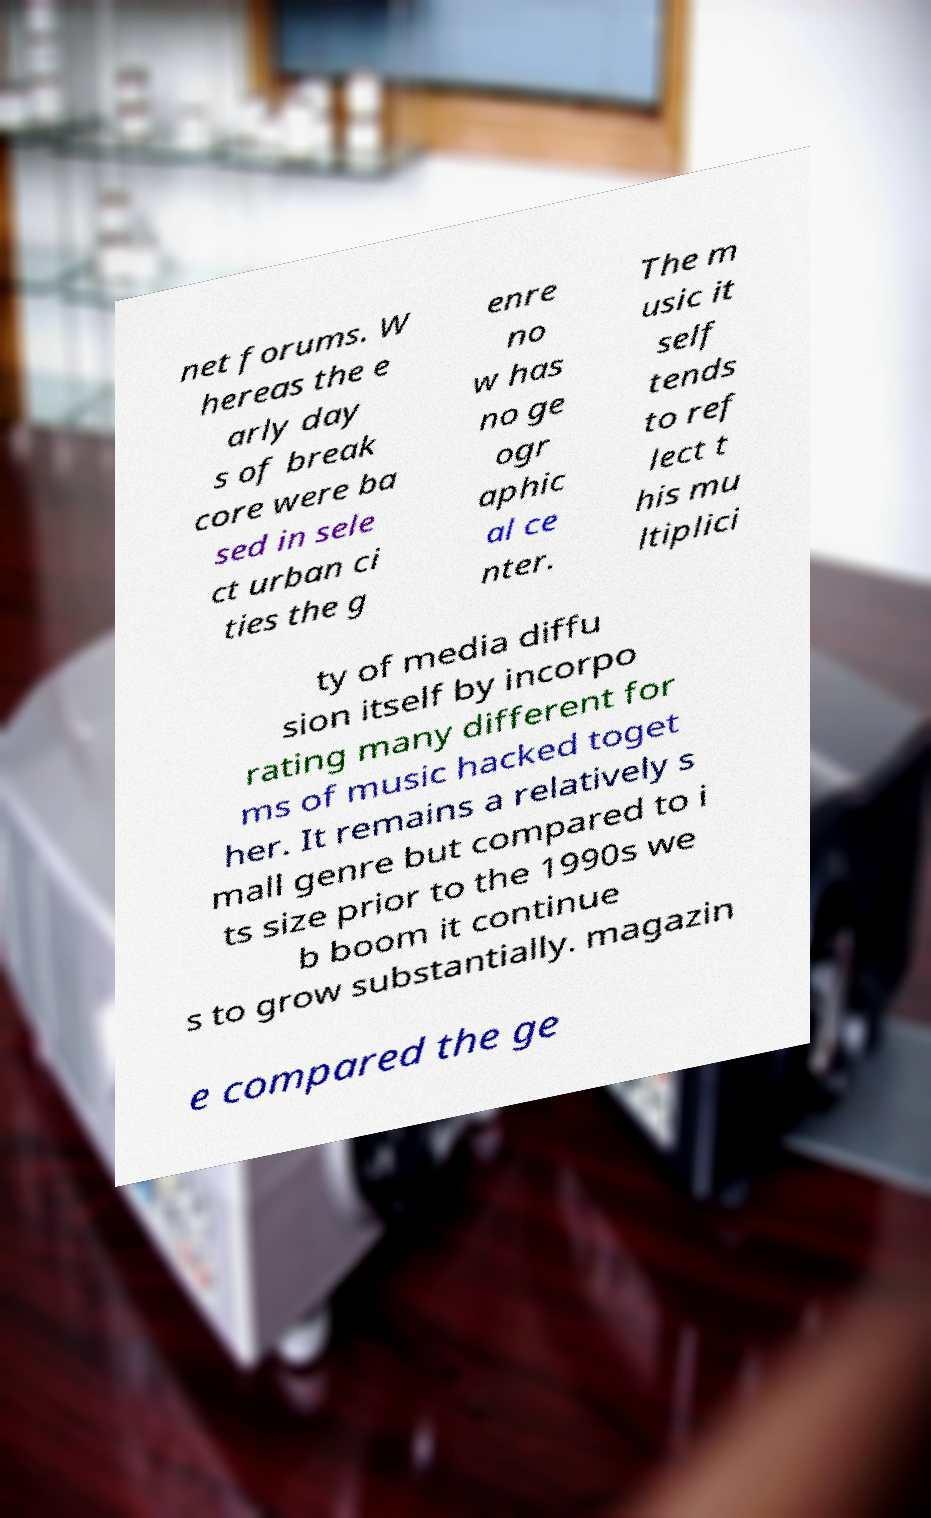Could you assist in decoding the text presented in this image and type it out clearly? net forums. W hereas the e arly day s of break core were ba sed in sele ct urban ci ties the g enre no w has no ge ogr aphic al ce nter. The m usic it self tends to ref lect t his mu ltiplici ty of media diffu sion itself by incorpo rating many different for ms of music hacked toget her. It remains a relatively s mall genre but compared to i ts size prior to the 1990s we b boom it continue s to grow substantially. magazin e compared the ge 